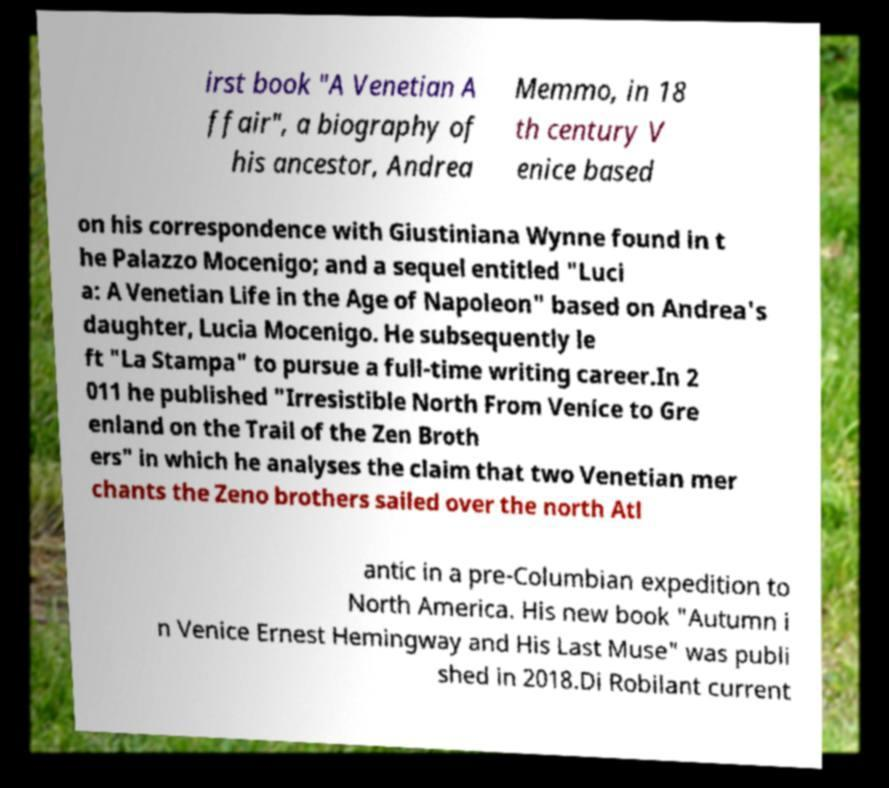What messages or text are displayed in this image? I need them in a readable, typed format. irst book "A Venetian A ffair", a biography of his ancestor, Andrea Memmo, in 18 th century V enice based on his correspondence with Giustiniana Wynne found in t he Palazzo Mocenigo; and a sequel entitled "Luci a: A Venetian Life in the Age of Napoleon" based on Andrea's daughter, Lucia Mocenigo. He subsequently le ft "La Stampa" to pursue a full-time writing career.In 2 011 he published "Irresistible North From Venice to Gre enland on the Trail of the Zen Broth ers" in which he analyses the claim that two Venetian mer chants the Zeno brothers sailed over the north Atl antic in a pre-Columbian expedition to North America. His new book "Autumn i n Venice Ernest Hemingway and His Last Muse" was publi shed in 2018.Di Robilant current 